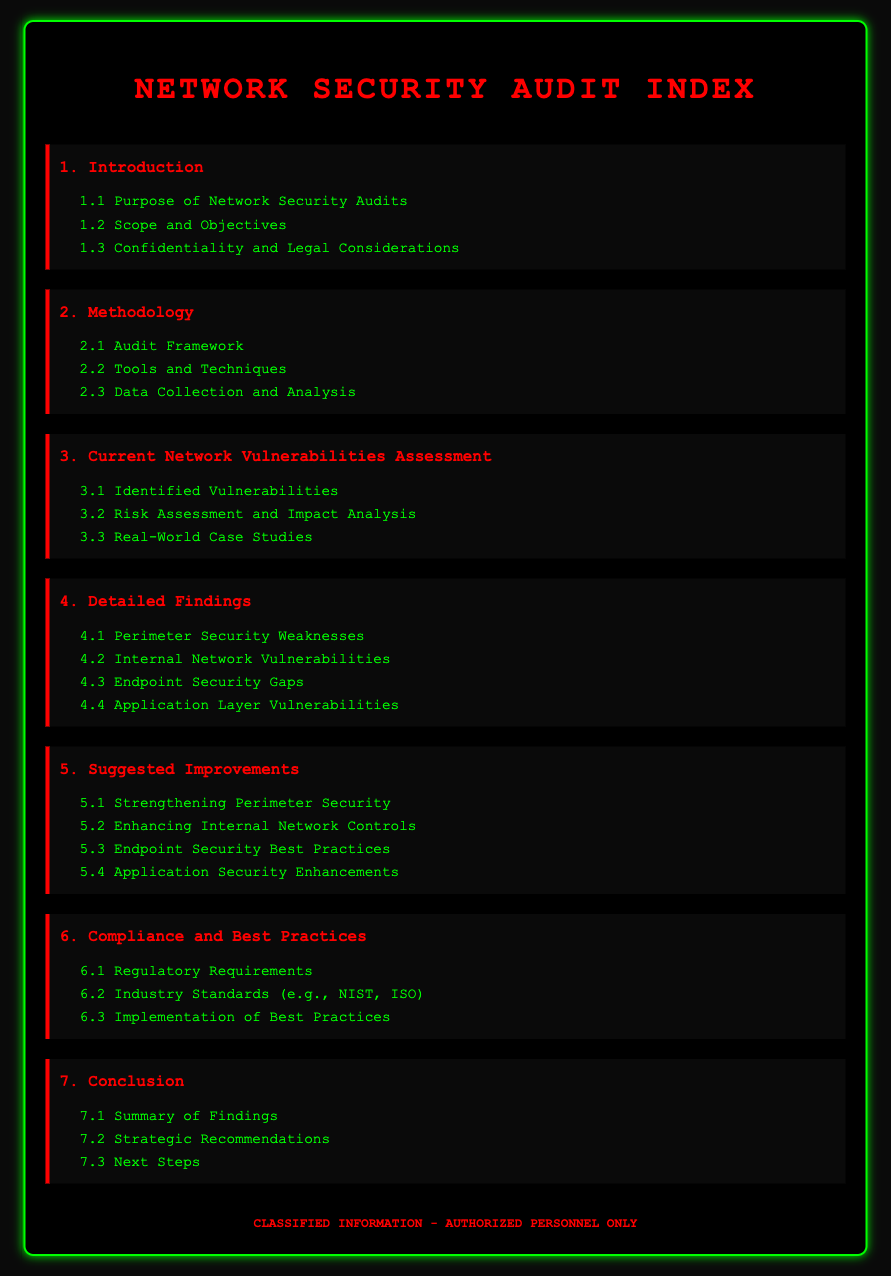What is the purpose of network security audits? The purpose is to assess and improve an organization's network security posture.
Answer: To assess and improve an organization's network security posture What section covers identified vulnerabilities? Identified vulnerabilities can be found under the section titled "Current Network Vulnerabilities Assessment."
Answer: Current Network Vulnerabilities Assessment How many subsections are in the "Suggested Improvements" section? There are four subsections within the "Suggested Improvements" section.
Answer: Four What is the title of the last section in the document? The title of the last section is "Conclusion."
Answer: Conclusion Which regulatory requirements are mentioned? Regulatory requirements are discussed in the "Compliance and Best Practices" section.
Answer: Compliance and Best Practices What is the background color of the body in the document? The background color of the body is dark gray, specified as #0a0a0a.
Answer: Dark gray What color represents the section titles? The section titles are represented in red color.
Answer: Red What is the warning message shown at the bottom of the document? The warning message indicates that the information is classified and only authorized personnel should access it.
Answer: Classified Information - Authorized Personnel Only 